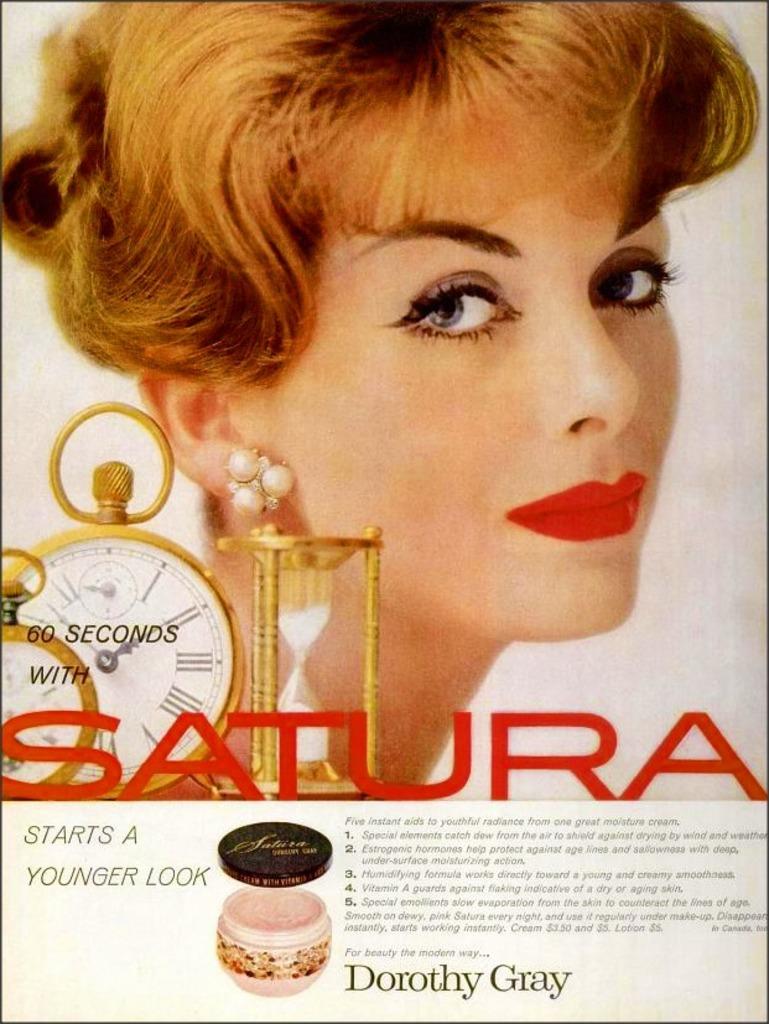What kind of look does that start?
Provide a short and direct response. Younger look. How many seconds?
Your response must be concise. 60. 